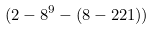Convert formula to latex. <formula><loc_0><loc_0><loc_500><loc_500>( 2 - 8 ^ { 9 } - ( 8 - 2 2 1 ) )</formula> 